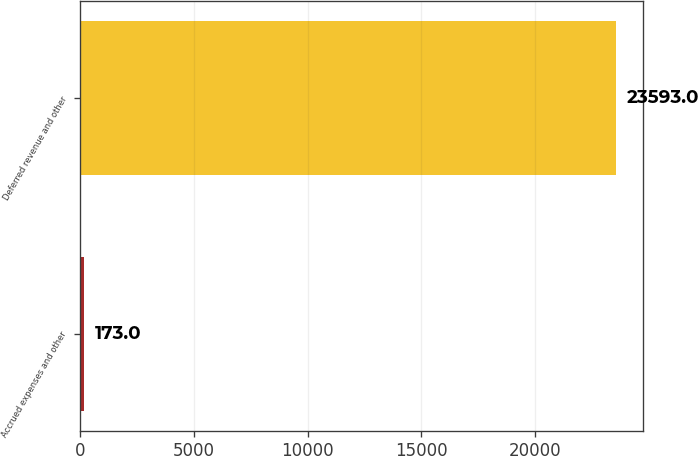Convert chart to OTSL. <chart><loc_0><loc_0><loc_500><loc_500><bar_chart><fcel>Accrued expenses and other<fcel>Deferred revenue and other<nl><fcel>173<fcel>23593<nl></chart> 